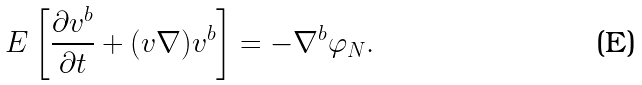<formula> <loc_0><loc_0><loc_500><loc_500>E \left [ \frac { \partial v ^ { b } } { \partial t } + ( v \nabla ) v ^ { b } \right ] = - \nabla ^ { b } \varphi _ { N } .</formula> 